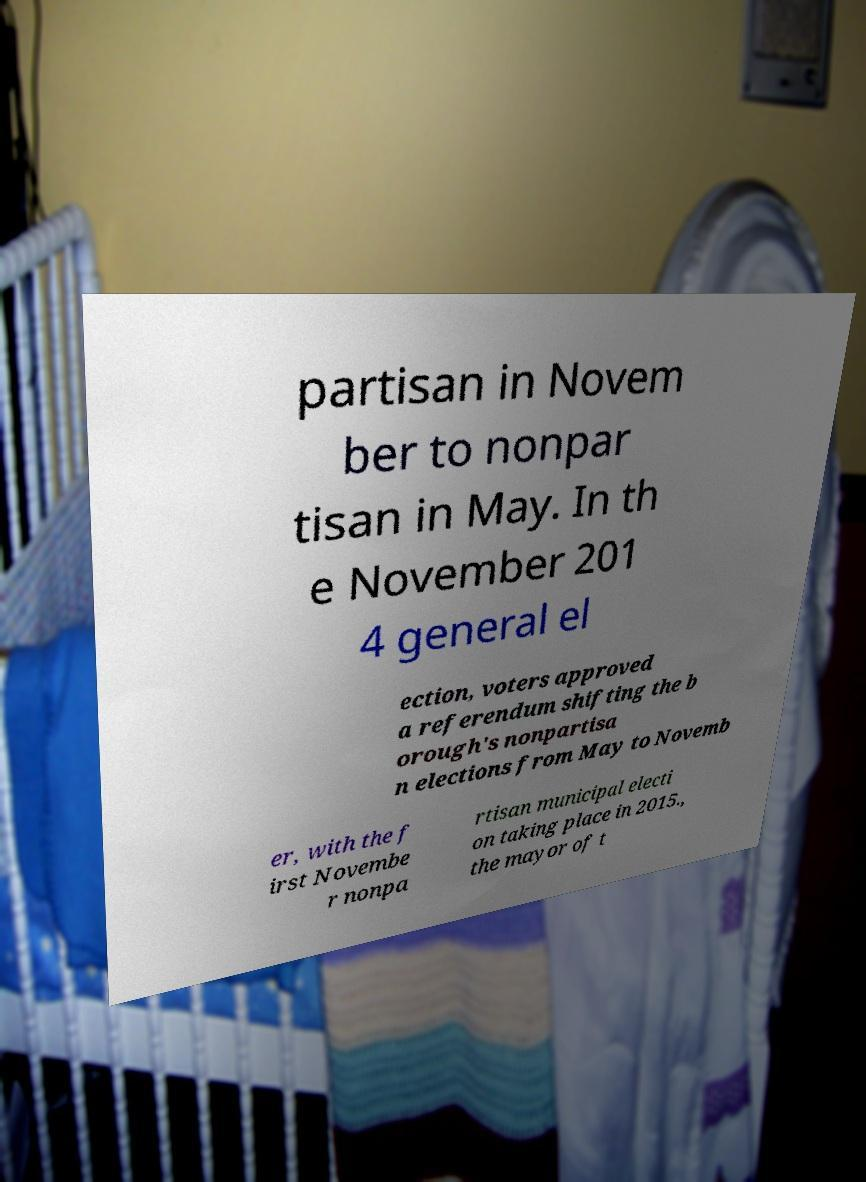There's text embedded in this image that I need extracted. Can you transcribe it verbatim? partisan in Novem ber to nonpar tisan in May. In th e November 201 4 general el ection, voters approved a referendum shifting the b orough's nonpartisa n elections from May to Novemb er, with the f irst Novembe r nonpa rtisan municipal electi on taking place in 2015., the mayor of t 